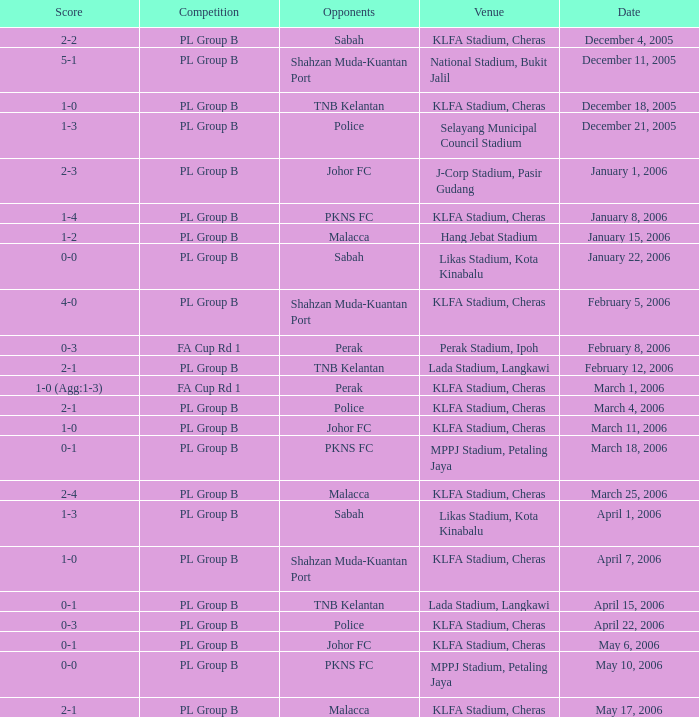Which Competition has Opponents of pkns fc, and a Score of 0-0? PL Group B. 